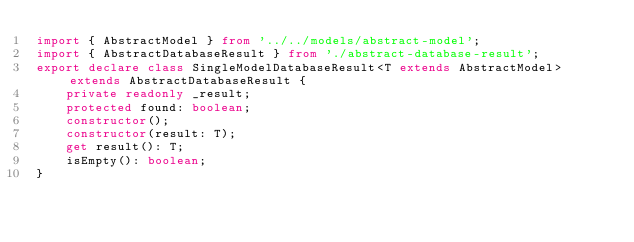<code> <loc_0><loc_0><loc_500><loc_500><_TypeScript_>import { AbstractModel } from '../../models/abstract-model';
import { AbstractDatabaseResult } from './abstract-database-result';
export declare class SingleModelDatabaseResult<T extends AbstractModel> extends AbstractDatabaseResult {
    private readonly _result;
    protected found: boolean;
    constructor();
    constructor(result: T);
    get result(): T;
    isEmpty(): boolean;
}</code> 